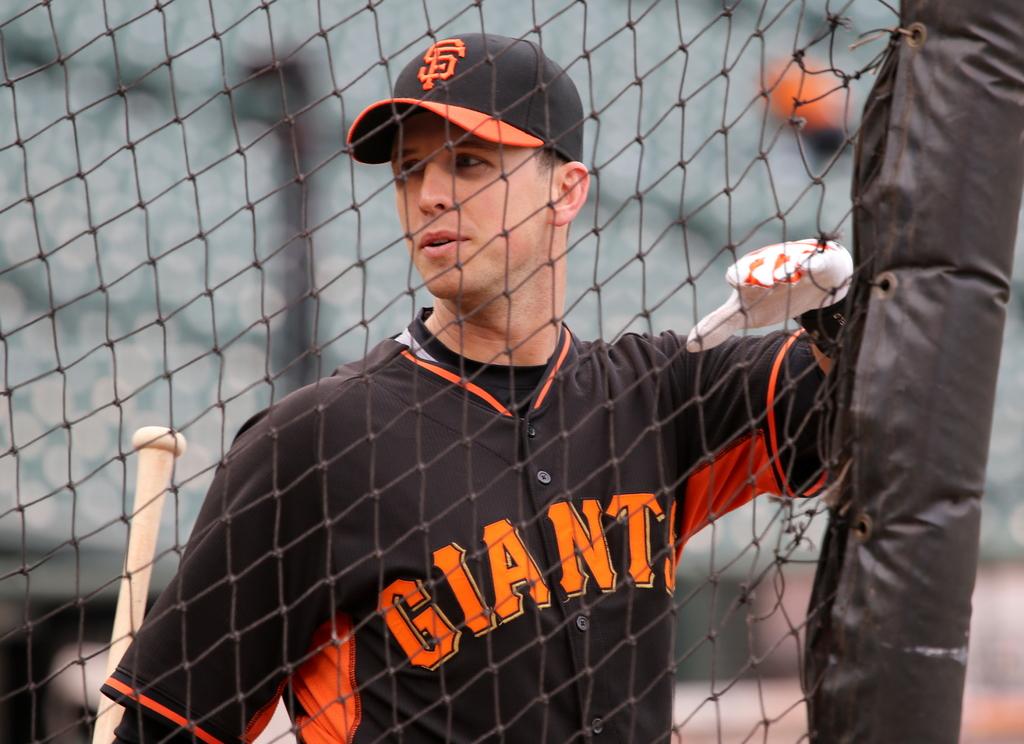What are the letters on his hat?
Make the answer very short. Sf. 